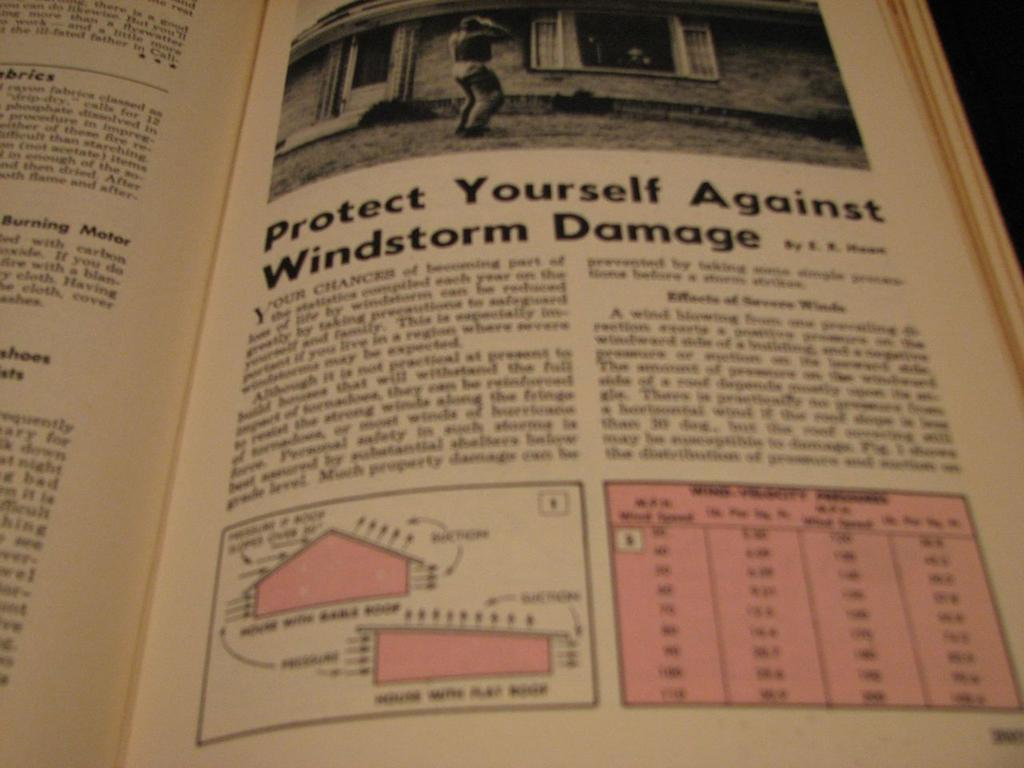<image>
Provide a brief description of the given image. A book opened to a page titled Protect Yourself Against Windstorm Damage. 